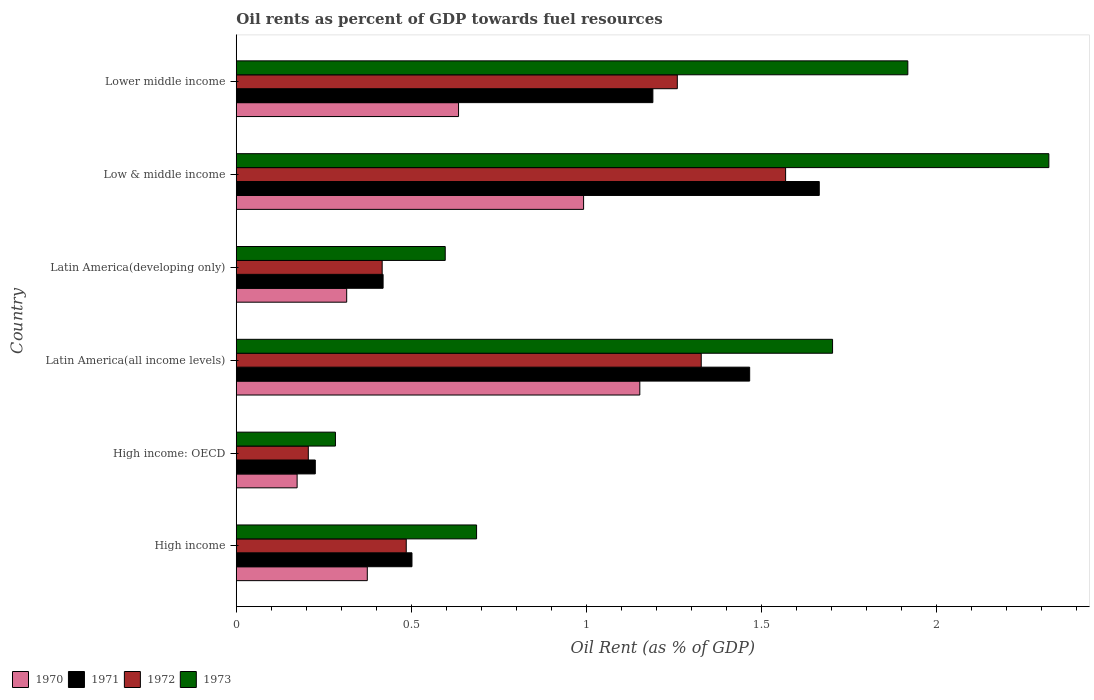How many groups of bars are there?
Offer a terse response. 6. Are the number of bars on each tick of the Y-axis equal?
Give a very brief answer. Yes. How many bars are there on the 6th tick from the top?
Your answer should be compact. 4. How many bars are there on the 2nd tick from the bottom?
Offer a very short reply. 4. What is the oil rent in 1973 in Latin America(developing only)?
Offer a terse response. 0.6. Across all countries, what is the maximum oil rent in 1973?
Keep it short and to the point. 2.32. Across all countries, what is the minimum oil rent in 1971?
Ensure brevity in your answer.  0.23. In which country was the oil rent in 1970 maximum?
Ensure brevity in your answer.  Latin America(all income levels). In which country was the oil rent in 1972 minimum?
Keep it short and to the point. High income: OECD. What is the total oil rent in 1973 in the graph?
Ensure brevity in your answer.  7.51. What is the difference between the oil rent in 1972 in High income and that in High income: OECD?
Offer a very short reply. 0.28. What is the difference between the oil rent in 1972 in Latin America(all income levels) and the oil rent in 1973 in High income: OECD?
Give a very brief answer. 1.04. What is the average oil rent in 1971 per country?
Your response must be concise. 0.91. What is the difference between the oil rent in 1971 and oil rent in 1970 in Latin America(all income levels)?
Your response must be concise. 0.31. In how many countries, is the oil rent in 1973 greater than 1.9 %?
Ensure brevity in your answer.  2. What is the ratio of the oil rent in 1973 in High income to that in High income: OECD?
Your answer should be compact. 2.42. Is the difference between the oil rent in 1971 in High income and Low & middle income greater than the difference between the oil rent in 1970 in High income and Low & middle income?
Ensure brevity in your answer.  No. What is the difference between the highest and the second highest oil rent in 1972?
Your response must be concise. 0.24. What is the difference between the highest and the lowest oil rent in 1971?
Offer a terse response. 1.44. In how many countries, is the oil rent in 1972 greater than the average oil rent in 1972 taken over all countries?
Ensure brevity in your answer.  3. Is the sum of the oil rent in 1971 in High income and Latin America(developing only) greater than the maximum oil rent in 1972 across all countries?
Keep it short and to the point. No. What does the 2nd bar from the top in High income represents?
Keep it short and to the point. 1972. What does the 1st bar from the bottom in Latin America(developing only) represents?
Offer a very short reply. 1970. How many bars are there?
Ensure brevity in your answer.  24. Does the graph contain any zero values?
Give a very brief answer. No. Where does the legend appear in the graph?
Give a very brief answer. Bottom left. How many legend labels are there?
Keep it short and to the point. 4. How are the legend labels stacked?
Make the answer very short. Horizontal. What is the title of the graph?
Provide a succinct answer. Oil rents as percent of GDP towards fuel resources. Does "1995" appear as one of the legend labels in the graph?
Your response must be concise. No. What is the label or title of the X-axis?
Offer a terse response. Oil Rent (as % of GDP). What is the Oil Rent (as % of GDP) of 1970 in High income?
Give a very brief answer. 0.37. What is the Oil Rent (as % of GDP) of 1971 in High income?
Ensure brevity in your answer.  0.5. What is the Oil Rent (as % of GDP) of 1972 in High income?
Keep it short and to the point. 0.49. What is the Oil Rent (as % of GDP) in 1973 in High income?
Provide a short and direct response. 0.69. What is the Oil Rent (as % of GDP) in 1970 in High income: OECD?
Offer a terse response. 0.17. What is the Oil Rent (as % of GDP) of 1971 in High income: OECD?
Offer a very short reply. 0.23. What is the Oil Rent (as % of GDP) of 1972 in High income: OECD?
Provide a short and direct response. 0.21. What is the Oil Rent (as % of GDP) in 1973 in High income: OECD?
Provide a succinct answer. 0.28. What is the Oil Rent (as % of GDP) of 1970 in Latin America(all income levels)?
Ensure brevity in your answer.  1.15. What is the Oil Rent (as % of GDP) in 1971 in Latin America(all income levels)?
Give a very brief answer. 1.47. What is the Oil Rent (as % of GDP) in 1972 in Latin America(all income levels)?
Ensure brevity in your answer.  1.33. What is the Oil Rent (as % of GDP) in 1973 in Latin America(all income levels)?
Offer a very short reply. 1.7. What is the Oil Rent (as % of GDP) in 1970 in Latin America(developing only)?
Your answer should be compact. 0.32. What is the Oil Rent (as % of GDP) in 1971 in Latin America(developing only)?
Keep it short and to the point. 0.42. What is the Oil Rent (as % of GDP) in 1972 in Latin America(developing only)?
Provide a short and direct response. 0.42. What is the Oil Rent (as % of GDP) in 1973 in Latin America(developing only)?
Offer a terse response. 0.6. What is the Oil Rent (as % of GDP) of 1970 in Low & middle income?
Keep it short and to the point. 0.99. What is the Oil Rent (as % of GDP) of 1971 in Low & middle income?
Your answer should be very brief. 1.67. What is the Oil Rent (as % of GDP) of 1972 in Low & middle income?
Offer a terse response. 1.57. What is the Oil Rent (as % of GDP) in 1973 in Low & middle income?
Ensure brevity in your answer.  2.32. What is the Oil Rent (as % of GDP) in 1970 in Lower middle income?
Your answer should be compact. 0.63. What is the Oil Rent (as % of GDP) of 1971 in Lower middle income?
Provide a succinct answer. 1.19. What is the Oil Rent (as % of GDP) in 1972 in Lower middle income?
Offer a terse response. 1.26. What is the Oil Rent (as % of GDP) of 1973 in Lower middle income?
Your answer should be very brief. 1.92. Across all countries, what is the maximum Oil Rent (as % of GDP) of 1970?
Make the answer very short. 1.15. Across all countries, what is the maximum Oil Rent (as % of GDP) of 1971?
Make the answer very short. 1.67. Across all countries, what is the maximum Oil Rent (as % of GDP) of 1972?
Offer a very short reply. 1.57. Across all countries, what is the maximum Oil Rent (as % of GDP) of 1973?
Provide a short and direct response. 2.32. Across all countries, what is the minimum Oil Rent (as % of GDP) of 1970?
Give a very brief answer. 0.17. Across all countries, what is the minimum Oil Rent (as % of GDP) of 1971?
Give a very brief answer. 0.23. Across all countries, what is the minimum Oil Rent (as % of GDP) of 1972?
Offer a very short reply. 0.21. Across all countries, what is the minimum Oil Rent (as % of GDP) of 1973?
Offer a very short reply. 0.28. What is the total Oil Rent (as % of GDP) of 1970 in the graph?
Keep it short and to the point. 3.64. What is the total Oil Rent (as % of GDP) in 1971 in the graph?
Keep it short and to the point. 5.47. What is the total Oil Rent (as % of GDP) of 1972 in the graph?
Provide a succinct answer. 5.27. What is the total Oil Rent (as % of GDP) in 1973 in the graph?
Your answer should be very brief. 7.51. What is the difference between the Oil Rent (as % of GDP) in 1970 in High income and that in High income: OECD?
Make the answer very short. 0.2. What is the difference between the Oil Rent (as % of GDP) of 1971 in High income and that in High income: OECD?
Provide a succinct answer. 0.28. What is the difference between the Oil Rent (as % of GDP) in 1972 in High income and that in High income: OECD?
Make the answer very short. 0.28. What is the difference between the Oil Rent (as % of GDP) in 1973 in High income and that in High income: OECD?
Your answer should be compact. 0.4. What is the difference between the Oil Rent (as % of GDP) in 1970 in High income and that in Latin America(all income levels)?
Your answer should be very brief. -0.78. What is the difference between the Oil Rent (as % of GDP) of 1971 in High income and that in Latin America(all income levels)?
Ensure brevity in your answer.  -0.96. What is the difference between the Oil Rent (as % of GDP) in 1972 in High income and that in Latin America(all income levels)?
Give a very brief answer. -0.84. What is the difference between the Oil Rent (as % of GDP) of 1973 in High income and that in Latin America(all income levels)?
Offer a terse response. -1.02. What is the difference between the Oil Rent (as % of GDP) in 1970 in High income and that in Latin America(developing only)?
Offer a very short reply. 0.06. What is the difference between the Oil Rent (as % of GDP) of 1971 in High income and that in Latin America(developing only)?
Your answer should be very brief. 0.08. What is the difference between the Oil Rent (as % of GDP) in 1972 in High income and that in Latin America(developing only)?
Make the answer very short. 0.07. What is the difference between the Oil Rent (as % of GDP) in 1973 in High income and that in Latin America(developing only)?
Make the answer very short. 0.09. What is the difference between the Oil Rent (as % of GDP) in 1970 in High income and that in Low & middle income?
Provide a succinct answer. -0.62. What is the difference between the Oil Rent (as % of GDP) of 1971 in High income and that in Low & middle income?
Offer a terse response. -1.16. What is the difference between the Oil Rent (as % of GDP) of 1972 in High income and that in Low & middle income?
Provide a succinct answer. -1.08. What is the difference between the Oil Rent (as % of GDP) in 1973 in High income and that in Low & middle income?
Ensure brevity in your answer.  -1.63. What is the difference between the Oil Rent (as % of GDP) in 1970 in High income and that in Lower middle income?
Offer a terse response. -0.26. What is the difference between the Oil Rent (as % of GDP) of 1971 in High income and that in Lower middle income?
Offer a very short reply. -0.69. What is the difference between the Oil Rent (as % of GDP) in 1972 in High income and that in Lower middle income?
Your answer should be very brief. -0.77. What is the difference between the Oil Rent (as % of GDP) of 1973 in High income and that in Lower middle income?
Your answer should be very brief. -1.23. What is the difference between the Oil Rent (as % of GDP) in 1970 in High income: OECD and that in Latin America(all income levels)?
Provide a succinct answer. -0.98. What is the difference between the Oil Rent (as % of GDP) in 1971 in High income: OECD and that in Latin America(all income levels)?
Your answer should be compact. -1.24. What is the difference between the Oil Rent (as % of GDP) in 1972 in High income: OECD and that in Latin America(all income levels)?
Offer a very short reply. -1.12. What is the difference between the Oil Rent (as % of GDP) in 1973 in High income: OECD and that in Latin America(all income levels)?
Your answer should be very brief. -1.42. What is the difference between the Oil Rent (as % of GDP) of 1970 in High income: OECD and that in Latin America(developing only)?
Your answer should be very brief. -0.14. What is the difference between the Oil Rent (as % of GDP) of 1971 in High income: OECD and that in Latin America(developing only)?
Keep it short and to the point. -0.19. What is the difference between the Oil Rent (as % of GDP) of 1972 in High income: OECD and that in Latin America(developing only)?
Give a very brief answer. -0.21. What is the difference between the Oil Rent (as % of GDP) in 1973 in High income: OECD and that in Latin America(developing only)?
Offer a very short reply. -0.31. What is the difference between the Oil Rent (as % of GDP) in 1970 in High income: OECD and that in Low & middle income?
Provide a succinct answer. -0.82. What is the difference between the Oil Rent (as % of GDP) in 1971 in High income: OECD and that in Low & middle income?
Your response must be concise. -1.44. What is the difference between the Oil Rent (as % of GDP) in 1972 in High income: OECD and that in Low & middle income?
Your answer should be compact. -1.36. What is the difference between the Oil Rent (as % of GDP) of 1973 in High income: OECD and that in Low & middle income?
Ensure brevity in your answer.  -2.04. What is the difference between the Oil Rent (as % of GDP) of 1970 in High income: OECD and that in Lower middle income?
Provide a succinct answer. -0.46. What is the difference between the Oil Rent (as % of GDP) in 1971 in High income: OECD and that in Lower middle income?
Make the answer very short. -0.96. What is the difference between the Oil Rent (as % of GDP) of 1972 in High income: OECD and that in Lower middle income?
Offer a very short reply. -1.05. What is the difference between the Oil Rent (as % of GDP) of 1973 in High income: OECD and that in Lower middle income?
Ensure brevity in your answer.  -1.64. What is the difference between the Oil Rent (as % of GDP) of 1970 in Latin America(all income levels) and that in Latin America(developing only)?
Make the answer very short. 0.84. What is the difference between the Oil Rent (as % of GDP) of 1971 in Latin America(all income levels) and that in Latin America(developing only)?
Give a very brief answer. 1.05. What is the difference between the Oil Rent (as % of GDP) in 1972 in Latin America(all income levels) and that in Latin America(developing only)?
Your answer should be compact. 0.91. What is the difference between the Oil Rent (as % of GDP) of 1973 in Latin America(all income levels) and that in Latin America(developing only)?
Provide a short and direct response. 1.11. What is the difference between the Oil Rent (as % of GDP) of 1970 in Latin America(all income levels) and that in Low & middle income?
Provide a short and direct response. 0.16. What is the difference between the Oil Rent (as % of GDP) in 1971 in Latin America(all income levels) and that in Low & middle income?
Offer a very short reply. -0.2. What is the difference between the Oil Rent (as % of GDP) of 1972 in Latin America(all income levels) and that in Low & middle income?
Ensure brevity in your answer.  -0.24. What is the difference between the Oil Rent (as % of GDP) of 1973 in Latin America(all income levels) and that in Low & middle income?
Your answer should be very brief. -0.62. What is the difference between the Oil Rent (as % of GDP) in 1970 in Latin America(all income levels) and that in Lower middle income?
Your response must be concise. 0.52. What is the difference between the Oil Rent (as % of GDP) in 1971 in Latin America(all income levels) and that in Lower middle income?
Offer a terse response. 0.28. What is the difference between the Oil Rent (as % of GDP) of 1972 in Latin America(all income levels) and that in Lower middle income?
Offer a terse response. 0.07. What is the difference between the Oil Rent (as % of GDP) of 1973 in Latin America(all income levels) and that in Lower middle income?
Give a very brief answer. -0.21. What is the difference between the Oil Rent (as % of GDP) in 1970 in Latin America(developing only) and that in Low & middle income?
Your answer should be very brief. -0.68. What is the difference between the Oil Rent (as % of GDP) in 1971 in Latin America(developing only) and that in Low & middle income?
Offer a very short reply. -1.25. What is the difference between the Oil Rent (as % of GDP) in 1972 in Latin America(developing only) and that in Low & middle income?
Your answer should be very brief. -1.15. What is the difference between the Oil Rent (as % of GDP) in 1973 in Latin America(developing only) and that in Low & middle income?
Your response must be concise. -1.72. What is the difference between the Oil Rent (as % of GDP) of 1970 in Latin America(developing only) and that in Lower middle income?
Offer a terse response. -0.32. What is the difference between the Oil Rent (as % of GDP) of 1971 in Latin America(developing only) and that in Lower middle income?
Offer a terse response. -0.77. What is the difference between the Oil Rent (as % of GDP) of 1972 in Latin America(developing only) and that in Lower middle income?
Your response must be concise. -0.84. What is the difference between the Oil Rent (as % of GDP) of 1973 in Latin America(developing only) and that in Lower middle income?
Offer a terse response. -1.32. What is the difference between the Oil Rent (as % of GDP) of 1970 in Low & middle income and that in Lower middle income?
Ensure brevity in your answer.  0.36. What is the difference between the Oil Rent (as % of GDP) of 1971 in Low & middle income and that in Lower middle income?
Ensure brevity in your answer.  0.48. What is the difference between the Oil Rent (as % of GDP) in 1972 in Low & middle income and that in Lower middle income?
Keep it short and to the point. 0.31. What is the difference between the Oil Rent (as % of GDP) of 1973 in Low & middle income and that in Lower middle income?
Ensure brevity in your answer.  0.4. What is the difference between the Oil Rent (as % of GDP) of 1970 in High income and the Oil Rent (as % of GDP) of 1971 in High income: OECD?
Keep it short and to the point. 0.15. What is the difference between the Oil Rent (as % of GDP) in 1970 in High income and the Oil Rent (as % of GDP) in 1972 in High income: OECD?
Offer a terse response. 0.17. What is the difference between the Oil Rent (as % of GDP) of 1970 in High income and the Oil Rent (as % of GDP) of 1973 in High income: OECD?
Provide a succinct answer. 0.09. What is the difference between the Oil Rent (as % of GDP) of 1971 in High income and the Oil Rent (as % of GDP) of 1972 in High income: OECD?
Provide a short and direct response. 0.3. What is the difference between the Oil Rent (as % of GDP) of 1971 in High income and the Oil Rent (as % of GDP) of 1973 in High income: OECD?
Make the answer very short. 0.22. What is the difference between the Oil Rent (as % of GDP) in 1972 in High income and the Oil Rent (as % of GDP) in 1973 in High income: OECD?
Your answer should be compact. 0.2. What is the difference between the Oil Rent (as % of GDP) in 1970 in High income and the Oil Rent (as % of GDP) in 1971 in Latin America(all income levels)?
Ensure brevity in your answer.  -1.09. What is the difference between the Oil Rent (as % of GDP) in 1970 in High income and the Oil Rent (as % of GDP) in 1972 in Latin America(all income levels)?
Your response must be concise. -0.95. What is the difference between the Oil Rent (as % of GDP) of 1970 in High income and the Oil Rent (as % of GDP) of 1973 in Latin America(all income levels)?
Keep it short and to the point. -1.33. What is the difference between the Oil Rent (as % of GDP) of 1971 in High income and the Oil Rent (as % of GDP) of 1972 in Latin America(all income levels)?
Your answer should be compact. -0.83. What is the difference between the Oil Rent (as % of GDP) of 1971 in High income and the Oil Rent (as % of GDP) of 1973 in Latin America(all income levels)?
Provide a succinct answer. -1.2. What is the difference between the Oil Rent (as % of GDP) of 1972 in High income and the Oil Rent (as % of GDP) of 1973 in Latin America(all income levels)?
Ensure brevity in your answer.  -1.22. What is the difference between the Oil Rent (as % of GDP) in 1970 in High income and the Oil Rent (as % of GDP) in 1971 in Latin America(developing only)?
Your answer should be very brief. -0.05. What is the difference between the Oil Rent (as % of GDP) in 1970 in High income and the Oil Rent (as % of GDP) in 1972 in Latin America(developing only)?
Give a very brief answer. -0.04. What is the difference between the Oil Rent (as % of GDP) of 1970 in High income and the Oil Rent (as % of GDP) of 1973 in Latin America(developing only)?
Your answer should be compact. -0.22. What is the difference between the Oil Rent (as % of GDP) in 1971 in High income and the Oil Rent (as % of GDP) in 1972 in Latin America(developing only)?
Ensure brevity in your answer.  0.09. What is the difference between the Oil Rent (as % of GDP) in 1971 in High income and the Oil Rent (as % of GDP) in 1973 in Latin America(developing only)?
Provide a short and direct response. -0.1. What is the difference between the Oil Rent (as % of GDP) in 1972 in High income and the Oil Rent (as % of GDP) in 1973 in Latin America(developing only)?
Ensure brevity in your answer.  -0.11. What is the difference between the Oil Rent (as % of GDP) in 1970 in High income and the Oil Rent (as % of GDP) in 1971 in Low & middle income?
Offer a terse response. -1.29. What is the difference between the Oil Rent (as % of GDP) in 1970 in High income and the Oil Rent (as % of GDP) in 1972 in Low & middle income?
Offer a terse response. -1.19. What is the difference between the Oil Rent (as % of GDP) in 1970 in High income and the Oil Rent (as % of GDP) in 1973 in Low & middle income?
Your answer should be very brief. -1.95. What is the difference between the Oil Rent (as % of GDP) of 1971 in High income and the Oil Rent (as % of GDP) of 1972 in Low & middle income?
Make the answer very short. -1.07. What is the difference between the Oil Rent (as % of GDP) of 1971 in High income and the Oil Rent (as % of GDP) of 1973 in Low & middle income?
Your response must be concise. -1.82. What is the difference between the Oil Rent (as % of GDP) of 1972 in High income and the Oil Rent (as % of GDP) of 1973 in Low & middle income?
Give a very brief answer. -1.84. What is the difference between the Oil Rent (as % of GDP) in 1970 in High income and the Oil Rent (as % of GDP) in 1971 in Lower middle income?
Provide a short and direct response. -0.82. What is the difference between the Oil Rent (as % of GDP) in 1970 in High income and the Oil Rent (as % of GDP) in 1972 in Lower middle income?
Keep it short and to the point. -0.89. What is the difference between the Oil Rent (as % of GDP) of 1970 in High income and the Oil Rent (as % of GDP) of 1973 in Lower middle income?
Offer a very short reply. -1.54. What is the difference between the Oil Rent (as % of GDP) of 1971 in High income and the Oil Rent (as % of GDP) of 1972 in Lower middle income?
Your answer should be compact. -0.76. What is the difference between the Oil Rent (as % of GDP) of 1971 in High income and the Oil Rent (as % of GDP) of 1973 in Lower middle income?
Make the answer very short. -1.42. What is the difference between the Oil Rent (as % of GDP) of 1972 in High income and the Oil Rent (as % of GDP) of 1973 in Lower middle income?
Give a very brief answer. -1.43. What is the difference between the Oil Rent (as % of GDP) in 1970 in High income: OECD and the Oil Rent (as % of GDP) in 1971 in Latin America(all income levels)?
Provide a short and direct response. -1.29. What is the difference between the Oil Rent (as % of GDP) in 1970 in High income: OECD and the Oil Rent (as % of GDP) in 1972 in Latin America(all income levels)?
Make the answer very short. -1.15. What is the difference between the Oil Rent (as % of GDP) of 1970 in High income: OECD and the Oil Rent (as % of GDP) of 1973 in Latin America(all income levels)?
Provide a short and direct response. -1.53. What is the difference between the Oil Rent (as % of GDP) of 1971 in High income: OECD and the Oil Rent (as % of GDP) of 1972 in Latin America(all income levels)?
Your answer should be compact. -1.1. What is the difference between the Oil Rent (as % of GDP) of 1971 in High income: OECD and the Oil Rent (as % of GDP) of 1973 in Latin America(all income levels)?
Your answer should be very brief. -1.48. What is the difference between the Oil Rent (as % of GDP) in 1972 in High income: OECD and the Oil Rent (as % of GDP) in 1973 in Latin America(all income levels)?
Provide a short and direct response. -1.5. What is the difference between the Oil Rent (as % of GDP) of 1970 in High income: OECD and the Oil Rent (as % of GDP) of 1971 in Latin America(developing only)?
Provide a short and direct response. -0.25. What is the difference between the Oil Rent (as % of GDP) of 1970 in High income: OECD and the Oil Rent (as % of GDP) of 1972 in Latin America(developing only)?
Your answer should be compact. -0.24. What is the difference between the Oil Rent (as % of GDP) of 1970 in High income: OECD and the Oil Rent (as % of GDP) of 1973 in Latin America(developing only)?
Ensure brevity in your answer.  -0.42. What is the difference between the Oil Rent (as % of GDP) in 1971 in High income: OECD and the Oil Rent (as % of GDP) in 1972 in Latin America(developing only)?
Provide a succinct answer. -0.19. What is the difference between the Oil Rent (as % of GDP) in 1971 in High income: OECD and the Oil Rent (as % of GDP) in 1973 in Latin America(developing only)?
Provide a short and direct response. -0.37. What is the difference between the Oil Rent (as % of GDP) in 1972 in High income: OECD and the Oil Rent (as % of GDP) in 1973 in Latin America(developing only)?
Ensure brevity in your answer.  -0.39. What is the difference between the Oil Rent (as % of GDP) of 1970 in High income: OECD and the Oil Rent (as % of GDP) of 1971 in Low & middle income?
Provide a succinct answer. -1.49. What is the difference between the Oil Rent (as % of GDP) in 1970 in High income: OECD and the Oil Rent (as % of GDP) in 1972 in Low & middle income?
Keep it short and to the point. -1.4. What is the difference between the Oil Rent (as % of GDP) in 1970 in High income: OECD and the Oil Rent (as % of GDP) in 1973 in Low & middle income?
Ensure brevity in your answer.  -2.15. What is the difference between the Oil Rent (as % of GDP) in 1971 in High income: OECD and the Oil Rent (as % of GDP) in 1972 in Low & middle income?
Make the answer very short. -1.34. What is the difference between the Oil Rent (as % of GDP) in 1971 in High income: OECD and the Oil Rent (as % of GDP) in 1973 in Low & middle income?
Your response must be concise. -2.1. What is the difference between the Oil Rent (as % of GDP) of 1972 in High income: OECD and the Oil Rent (as % of GDP) of 1973 in Low & middle income?
Provide a succinct answer. -2.12. What is the difference between the Oil Rent (as % of GDP) in 1970 in High income: OECD and the Oil Rent (as % of GDP) in 1971 in Lower middle income?
Your response must be concise. -1.02. What is the difference between the Oil Rent (as % of GDP) in 1970 in High income: OECD and the Oil Rent (as % of GDP) in 1972 in Lower middle income?
Ensure brevity in your answer.  -1.09. What is the difference between the Oil Rent (as % of GDP) of 1970 in High income: OECD and the Oil Rent (as % of GDP) of 1973 in Lower middle income?
Make the answer very short. -1.74. What is the difference between the Oil Rent (as % of GDP) in 1971 in High income: OECD and the Oil Rent (as % of GDP) in 1972 in Lower middle income?
Provide a succinct answer. -1.03. What is the difference between the Oil Rent (as % of GDP) of 1971 in High income: OECD and the Oil Rent (as % of GDP) of 1973 in Lower middle income?
Make the answer very short. -1.69. What is the difference between the Oil Rent (as % of GDP) of 1972 in High income: OECD and the Oil Rent (as % of GDP) of 1973 in Lower middle income?
Offer a terse response. -1.71. What is the difference between the Oil Rent (as % of GDP) of 1970 in Latin America(all income levels) and the Oil Rent (as % of GDP) of 1971 in Latin America(developing only)?
Give a very brief answer. 0.73. What is the difference between the Oil Rent (as % of GDP) of 1970 in Latin America(all income levels) and the Oil Rent (as % of GDP) of 1972 in Latin America(developing only)?
Give a very brief answer. 0.74. What is the difference between the Oil Rent (as % of GDP) in 1970 in Latin America(all income levels) and the Oil Rent (as % of GDP) in 1973 in Latin America(developing only)?
Make the answer very short. 0.56. What is the difference between the Oil Rent (as % of GDP) of 1971 in Latin America(all income levels) and the Oil Rent (as % of GDP) of 1972 in Latin America(developing only)?
Make the answer very short. 1.05. What is the difference between the Oil Rent (as % of GDP) in 1971 in Latin America(all income levels) and the Oil Rent (as % of GDP) in 1973 in Latin America(developing only)?
Provide a short and direct response. 0.87. What is the difference between the Oil Rent (as % of GDP) of 1972 in Latin America(all income levels) and the Oil Rent (as % of GDP) of 1973 in Latin America(developing only)?
Offer a very short reply. 0.73. What is the difference between the Oil Rent (as % of GDP) in 1970 in Latin America(all income levels) and the Oil Rent (as % of GDP) in 1971 in Low & middle income?
Ensure brevity in your answer.  -0.51. What is the difference between the Oil Rent (as % of GDP) in 1970 in Latin America(all income levels) and the Oil Rent (as % of GDP) in 1972 in Low & middle income?
Give a very brief answer. -0.42. What is the difference between the Oil Rent (as % of GDP) in 1970 in Latin America(all income levels) and the Oil Rent (as % of GDP) in 1973 in Low & middle income?
Make the answer very short. -1.17. What is the difference between the Oil Rent (as % of GDP) in 1971 in Latin America(all income levels) and the Oil Rent (as % of GDP) in 1972 in Low & middle income?
Your response must be concise. -0.1. What is the difference between the Oil Rent (as % of GDP) in 1971 in Latin America(all income levels) and the Oil Rent (as % of GDP) in 1973 in Low & middle income?
Give a very brief answer. -0.85. What is the difference between the Oil Rent (as % of GDP) in 1972 in Latin America(all income levels) and the Oil Rent (as % of GDP) in 1973 in Low & middle income?
Provide a succinct answer. -0.99. What is the difference between the Oil Rent (as % of GDP) in 1970 in Latin America(all income levels) and the Oil Rent (as % of GDP) in 1971 in Lower middle income?
Your answer should be compact. -0.04. What is the difference between the Oil Rent (as % of GDP) in 1970 in Latin America(all income levels) and the Oil Rent (as % of GDP) in 1972 in Lower middle income?
Your answer should be very brief. -0.11. What is the difference between the Oil Rent (as % of GDP) of 1970 in Latin America(all income levels) and the Oil Rent (as % of GDP) of 1973 in Lower middle income?
Offer a terse response. -0.77. What is the difference between the Oil Rent (as % of GDP) of 1971 in Latin America(all income levels) and the Oil Rent (as % of GDP) of 1972 in Lower middle income?
Ensure brevity in your answer.  0.21. What is the difference between the Oil Rent (as % of GDP) in 1971 in Latin America(all income levels) and the Oil Rent (as % of GDP) in 1973 in Lower middle income?
Offer a very short reply. -0.45. What is the difference between the Oil Rent (as % of GDP) in 1972 in Latin America(all income levels) and the Oil Rent (as % of GDP) in 1973 in Lower middle income?
Your answer should be compact. -0.59. What is the difference between the Oil Rent (as % of GDP) in 1970 in Latin America(developing only) and the Oil Rent (as % of GDP) in 1971 in Low & middle income?
Give a very brief answer. -1.35. What is the difference between the Oil Rent (as % of GDP) in 1970 in Latin America(developing only) and the Oil Rent (as % of GDP) in 1972 in Low & middle income?
Provide a succinct answer. -1.25. What is the difference between the Oil Rent (as % of GDP) in 1970 in Latin America(developing only) and the Oil Rent (as % of GDP) in 1973 in Low & middle income?
Provide a succinct answer. -2.01. What is the difference between the Oil Rent (as % of GDP) of 1971 in Latin America(developing only) and the Oil Rent (as % of GDP) of 1972 in Low & middle income?
Make the answer very short. -1.15. What is the difference between the Oil Rent (as % of GDP) of 1971 in Latin America(developing only) and the Oil Rent (as % of GDP) of 1973 in Low & middle income?
Your answer should be compact. -1.9. What is the difference between the Oil Rent (as % of GDP) of 1972 in Latin America(developing only) and the Oil Rent (as % of GDP) of 1973 in Low & middle income?
Give a very brief answer. -1.9. What is the difference between the Oil Rent (as % of GDP) of 1970 in Latin America(developing only) and the Oil Rent (as % of GDP) of 1971 in Lower middle income?
Ensure brevity in your answer.  -0.87. What is the difference between the Oil Rent (as % of GDP) in 1970 in Latin America(developing only) and the Oil Rent (as % of GDP) in 1972 in Lower middle income?
Offer a very short reply. -0.94. What is the difference between the Oil Rent (as % of GDP) in 1970 in Latin America(developing only) and the Oil Rent (as % of GDP) in 1973 in Lower middle income?
Your answer should be very brief. -1.6. What is the difference between the Oil Rent (as % of GDP) of 1971 in Latin America(developing only) and the Oil Rent (as % of GDP) of 1972 in Lower middle income?
Offer a terse response. -0.84. What is the difference between the Oil Rent (as % of GDP) of 1971 in Latin America(developing only) and the Oil Rent (as % of GDP) of 1973 in Lower middle income?
Your answer should be very brief. -1.5. What is the difference between the Oil Rent (as % of GDP) in 1972 in Latin America(developing only) and the Oil Rent (as % of GDP) in 1973 in Lower middle income?
Offer a very short reply. -1.5. What is the difference between the Oil Rent (as % of GDP) of 1970 in Low & middle income and the Oil Rent (as % of GDP) of 1971 in Lower middle income?
Keep it short and to the point. -0.2. What is the difference between the Oil Rent (as % of GDP) of 1970 in Low & middle income and the Oil Rent (as % of GDP) of 1972 in Lower middle income?
Your response must be concise. -0.27. What is the difference between the Oil Rent (as % of GDP) in 1970 in Low & middle income and the Oil Rent (as % of GDP) in 1973 in Lower middle income?
Make the answer very short. -0.93. What is the difference between the Oil Rent (as % of GDP) in 1971 in Low & middle income and the Oil Rent (as % of GDP) in 1972 in Lower middle income?
Your answer should be very brief. 0.41. What is the difference between the Oil Rent (as % of GDP) in 1971 in Low & middle income and the Oil Rent (as % of GDP) in 1973 in Lower middle income?
Offer a terse response. -0.25. What is the difference between the Oil Rent (as % of GDP) of 1972 in Low & middle income and the Oil Rent (as % of GDP) of 1973 in Lower middle income?
Ensure brevity in your answer.  -0.35. What is the average Oil Rent (as % of GDP) of 1970 per country?
Offer a very short reply. 0.61. What is the average Oil Rent (as % of GDP) of 1971 per country?
Give a very brief answer. 0.91. What is the average Oil Rent (as % of GDP) in 1972 per country?
Offer a very short reply. 0.88. What is the average Oil Rent (as % of GDP) in 1973 per country?
Make the answer very short. 1.25. What is the difference between the Oil Rent (as % of GDP) of 1970 and Oil Rent (as % of GDP) of 1971 in High income?
Your response must be concise. -0.13. What is the difference between the Oil Rent (as % of GDP) of 1970 and Oil Rent (as % of GDP) of 1972 in High income?
Ensure brevity in your answer.  -0.11. What is the difference between the Oil Rent (as % of GDP) of 1970 and Oil Rent (as % of GDP) of 1973 in High income?
Your answer should be very brief. -0.31. What is the difference between the Oil Rent (as % of GDP) in 1971 and Oil Rent (as % of GDP) in 1972 in High income?
Provide a succinct answer. 0.02. What is the difference between the Oil Rent (as % of GDP) in 1971 and Oil Rent (as % of GDP) in 1973 in High income?
Your response must be concise. -0.18. What is the difference between the Oil Rent (as % of GDP) of 1972 and Oil Rent (as % of GDP) of 1973 in High income?
Provide a succinct answer. -0.2. What is the difference between the Oil Rent (as % of GDP) of 1970 and Oil Rent (as % of GDP) of 1971 in High income: OECD?
Ensure brevity in your answer.  -0.05. What is the difference between the Oil Rent (as % of GDP) in 1970 and Oil Rent (as % of GDP) in 1972 in High income: OECD?
Ensure brevity in your answer.  -0.03. What is the difference between the Oil Rent (as % of GDP) of 1970 and Oil Rent (as % of GDP) of 1973 in High income: OECD?
Offer a very short reply. -0.11. What is the difference between the Oil Rent (as % of GDP) of 1971 and Oil Rent (as % of GDP) of 1973 in High income: OECD?
Give a very brief answer. -0.06. What is the difference between the Oil Rent (as % of GDP) of 1972 and Oil Rent (as % of GDP) of 1973 in High income: OECD?
Ensure brevity in your answer.  -0.08. What is the difference between the Oil Rent (as % of GDP) in 1970 and Oil Rent (as % of GDP) in 1971 in Latin America(all income levels)?
Your answer should be compact. -0.31. What is the difference between the Oil Rent (as % of GDP) of 1970 and Oil Rent (as % of GDP) of 1972 in Latin America(all income levels)?
Provide a succinct answer. -0.18. What is the difference between the Oil Rent (as % of GDP) of 1970 and Oil Rent (as % of GDP) of 1973 in Latin America(all income levels)?
Offer a very short reply. -0.55. What is the difference between the Oil Rent (as % of GDP) in 1971 and Oil Rent (as % of GDP) in 1972 in Latin America(all income levels)?
Provide a succinct answer. 0.14. What is the difference between the Oil Rent (as % of GDP) of 1971 and Oil Rent (as % of GDP) of 1973 in Latin America(all income levels)?
Offer a very short reply. -0.24. What is the difference between the Oil Rent (as % of GDP) in 1972 and Oil Rent (as % of GDP) in 1973 in Latin America(all income levels)?
Make the answer very short. -0.38. What is the difference between the Oil Rent (as % of GDP) in 1970 and Oil Rent (as % of GDP) in 1971 in Latin America(developing only)?
Give a very brief answer. -0.1. What is the difference between the Oil Rent (as % of GDP) of 1970 and Oil Rent (as % of GDP) of 1972 in Latin America(developing only)?
Provide a succinct answer. -0.1. What is the difference between the Oil Rent (as % of GDP) in 1970 and Oil Rent (as % of GDP) in 1973 in Latin America(developing only)?
Your answer should be compact. -0.28. What is the difference between the Oil Rent (as % of GDP) in 1971 and Oil Rent (as % of GDP) in 1972 in Latin America(developing only)?
Provide a succinct answer. 0. What is the difference between the Oil Rent (as % of GDP) of 1971 and Oil Rent (as % of GDP) of 1973 in Latin America(developing only)?
Offer a terse response. -0.18. What is the difference between the Oil Rent (as % of GDP) in 1972 and Oil Rent (as % of GDP) in 1973 in Latin America(developing only)?
Provide a short and direct response. -0.18. What is the difference between the Oil Rent (as % of GDP) of 1970 and Oil Rent (as % of GDP) of 1971 in Low & middle income?
Offer a terse response. -0.67. What is the difference between the Oil Rent (as % of GDP) of 1970 and Oil Rent (as % of GDP) of 1972 in Low & middle income?
Ensure brevity in your answer.  -0.58. What is the difference between the Oil Rent (as % of GDP) of 1970 and Oil Rent (as % of GDP) of 1973 in Low & middle income?
Make the answer very short. -1.33. What is the difference between the Oil Rent (as % of GDP) in 1971 and Oil Rent (as % of GDP) in 1972 in Low & middle income?
Keep it short and to the point. 0.1. What is the difference between the Oil Rent (as % of GDP) of 1971 and Oil Rent (as % of GDP) of 1973 in Low & middle income?
Give a very brief answer. -0.66. What is the difference between the Oil Rent (as % of GDP) in 1972 and Oil Rent (as % of GDP) in 1973 in Low & middle income?
Make the answer very short. -0.75. What is the difference between the Oil Rent (as % of GDP) in 1970 and Oil Rent (as % of GDP) in 1971 in Lower middle income?
Provide a short and direct response. -0.56. What is the difference between the Oil Rent (as % of GDP) of 1970 and Oil Rent (as % of GDP) of 1972 in Lower middle income?
Keep it short and to the point. -0.62. What is the difference between the Oil Rent (as % of GDP) of 1970 and Oil Rent (as % of GDP) of 1973 in Lower middle income?
Your response must be concise. -1.28. What is the difference between the Oil Rent (as % of GDP) in 1971 and Oil Rent (as % of GDP) in 1972 in Lower middle income?
Give a very brief answer. -0.07. What is the difference between the Oil Rent (as % of GDP) of 1971 and Oil Rent (as % of GDP) of 1973 in Lower middle income?
Make the answer very short. -0.73. What is the difference between the Oil Rent (as % of GDP) of 1972 and Oil Rent (as % of GDP) of 1973 in Lower middle income?
Provide a short and direct response. -0.66. What is the ratio of the Oil Rent (as % of GDP) of 1970 in High income to that in High income: OECD?
Your answer should be compact. 2.15. What is the ratio of the Oil Rent (as % of GDP) of 1971 in High income to that in High income: OECD?
Keep it short and to the point. 2.22. What is the ratio of the Oil Rent (as % of GDP) of 1972 in High income to that in High income: OECD?
Keep it short and to the point. 2.36. What is the ratio of the Oil Rent (as % of GDP) in 1973 in High income to that in High income: OECD?
Ensure brevity in your answer.  2.42. What is the ratio of the Oil Rent (as % of GDP) in 1970 in High income to that in Latin America(all income levels)?
Ensure brevity in your answer.  0.32. What is the ratio of the Oil Rent (as % of GDP) in 1971 in High income to that in Latin America(all income levels)?
Make the answer very short. 0.34. What is the ratio of the Oil Rent (as % of GDP) of 1972 in High income to that in Latin America(all income levels)?
Ensure brevity in your answer.  0.37. What is the ratio of the Oil Rent (as % of GDP) of 1973 in High income to that in Latin America(all income levels)?
Your answer should be compact. 0.4. What is the ratio of the Oil Rent (as % of GDP) of 1970 in High income to that in Latin America(developing only)?
Keep it short and to the point. 1.19. What is the ratio of the Oil Rent (as % of GDP) of 1971 in High income to that in Latin America(developing only)?
Make the answer very short. 1.2. What is the ratio of the Oil Rent (as % of GDP) in 1972 in High income to that in Latin America(developing only)?
Your answer should be compact. 1.17. What is the ratio of the Oil Rent (as % of GDP) of 1973 in High income to that in Latin America(developing only)?
Provide a succinct answer. 1.15. What is the ratio of the Oil Rent (as % of GDP) of 1970 in High income to that in Low & middle income?
Give a very brief answer. 0.38. What is the ratio of the Oil Rent (as % of GDP) of 1971 in High income to that in Low & middle income?
Your answer should be very brief. 0.3. What is the ratio of the Oil Rent (as % of GDP) in 1972 in High income to that in Low & middle income?
Your response must be concise. 0.31. What is the ratio of the Oil Rent (as % of GDP) in 1973 in High income to that in Low & middle income?
Keep it short and to the point. 0.3. What is the ratio of the Oil Rent (as % of GDP) of 1970 in High income to that in Lower middle income?
Your answer should be compact. 0.59. What is the ratio of the Oil Rent (as % of GDP) of 1971 in High income to that in Lower middle income?
Provide a short and direct response. 0.42. What is the ratio of the Oil Rent (as % of GDP) in 1972 in High income to that in Lower middle income?
Your answer should be very brief. 0.39. What is the ratio of the Oil Rent (as % of GDP) of 1973 in High income to that in Lower middle income?
Provide a succinct answer. 0.36. What is the ratio of the Oil Rent (as % of GDP) of 1970 in High income: OECD to that in Latin America(all income levels)?
Your answer should be very brief. 0.15. What is the ratio of the Oil Rent (as % of GDP) of 1971 in High income: OECD to that in Latin America(all income levels)?
Your answer should be compact. 0.15. What is the ratio of the Oil Rent (as % of GDP) in 1972 in High income: OECD to that in Latin America(all income levels)?
Make the answer very short. 0.15. What is the ratio of the Oil Rent (as % of GDP) of 1973 in High income: OECD to that in Latin America(all income levels)?
Offer a terse response. 0.17. What is the ratio of the Oil Rent (as % of GDP) in 1970 in High income: OECD to that in Latin America(developing only)?
Your response must be concise. 0.55. What is the ratio of the Oil Rent (as % of GDP) of 1971 in High income: OECD to that in Latin America(developing only)?
Offer a terse response. 0.54. What is the ratio of the Oil Rent (as % of GDP) in 1972 in High income: OECD to that in Latin America(developing only)?
Offer a terse response. 0.49. What is the ratio of the Oil Rent (as % of GDP) in 1973 in High income: OECD to that in Latin America(developing only)?
Make the answer very short. 0.47. What is the ratio of the Oil Rent (as % of GDP) in 1970 in High income: OECD to that in Low & middle income?
Keep it short and to the point. 0.18. What is the ratio of the Oil Rent (as % of GDP) in 1971 in High income: OECD to that in Low & middle income?
Your answer should be compact. 0.14. What is the ratio of the Oil Rent (as % of GDP) in 1972 in High income: OECD to that in Low & middle income?
Make the answer very short. 0.13. What is the ratio of the Oil Rent (as % of GDP) in 1973 in High income: OECD to that in Low & middle income?
Provide a succinct answer. 0.12. What is the ratio of the Oil Rent (as % of GDP) in 1970 in High income: OECD to that in Lower middle income?
Provide a succinct answer. 0.27. What is the ratio of the Oil Rent (as % of GDP) of 1971 in High income: OECD to that in Lower middle income?
Offer a very short reply. 0.19. What is the ratio of the Oil Rent (as % of GDP) in 1972 in High income: OECD to that in Lower middle income?
Provide a succinct answer. 0.16. What is the ratio of the Oil Rent (as % of GDP) in 1973 in High income: OECD to that in Lower middle income?
Ensure brevity in your answer.  0.15. What is the ratio of the Oil Rent (as % of GDP) in 1970 in Latin America(all income levels) to that in Latin America(developing only)?
Provide a short and direct response. 3.65. What is the ratio of the Oil Rent (as % of GDP) of 1971 in Latin America(all income levels) to that in Latin America(developing only)?
Your answer should be very brief. 3.5. What is the ratio of the Oil Rent (as % of GDP) in 1972 in Latin America(all income levels) to that in Latin America(developing only)?
Give a very brief answer. 3.19. What is the ratio of the Oil Rent (as % of GDP) of 1973 in Latin America(all income levels) to that in Latin America(developing only)?
Your answer should be very brief. 2.85. What is the ratio of the Oil Rent (as % of GDP) in 1970 in Latin America(all income levels) to that in Low & middle income?
Offer a very short reply. 1.16. What is the ratio of the Oil Rent (as % of GDP) of 1971 in Latin America(all income levels) to that in Low & middle income?
Offer a terse response. 0.88. What is the ratio of the Oil Rent (as % of GDP) of 1972 in Latin America(all income levels) to that in Low & middle income?
Provide a succinct answer. 0.85. What is the ratio of the Oil Rent (as % of GDP) of 1973 in Latin America(all income levels) to that in Low & middle income?
Offer a very short reply. 0.73. What is the ratio of the Oil Rent (as % of GDP) in 1970 in Latin America(all income levels) to that in Lower middle income?
Give a very brief answer. 1.82. What is the ratio of the Oil Rent (as % of GDP) in 1971 in Latin America(all income levels) to that in Lower middle income?
Provide a succinct answer. 1.23. What is the ratio of the Oil Rent (as % of GDP) in 1972 in Latin America(all income levels) to that in Lower middle income?
Provide a short and direct response. 1.05. What is the ratio of the Oil Rent (as % of GDP) in 1973 in Latin America(all income levels) to that in Lower middle income?
Offer a very short reply. 0.89. What is the ratio of the Oil Rent (as % of GDP) in 1970 in Latin America(developing only) to that in Low & middle income?
Your answer should be very brief. 0.32. What is the ratio of the Oil Rent (as % of GDP) of 1971 in Latin America(developing only) to that in Low & middle income?
Your answer should be very brief. 0.25. What is the ratio of the Oil Rent (as % of GDP) of 1972 in Latin America(developing only) to that in Low & middle income?
Your answer should be compact. 0.27. What is the ratio of the Oil Rent (as % of GDP) in 1973 in Latin America(developing only) to that in Low & middle income?
Provide a short and direct response. 0.26. What is the ratio of the Oil Rent (as % of GDP) of 1970 in Latin America(developing only) to that in Lower middle income?
Provide a short and direct response. 0.5. What is the ratio of the Oil Rent (as % of GDP) in 1971 in Latin America(developing only) to that in Lower middle income?
Provide a succinct answer. 0.35. What is the ratio of the Oil Rent (as % of GDP) in 1972 in Latin America(developing only) to that in Lower middle income?
Provide a short and direct response. 0.33. What is the ratio of the Oil Rent (as % of GDP) in 1973 in Latin America(developing only) to that in Lower middle income?
Provide a succinct answer. 0.31. What is the ratio of the Oil Rent (as % of GDP) of 1970 in Low & middle income to that in Lower middle income?
Your answer should be very brief. 1.56. What is the ratio of the Oil Rent (as % of GDP) in 1971 in Low & middle income to that in Lower middle income?
Your answer should be very brief. 1.4. What is the ratio of the Oil Rent (as % of GDP) in 1972 in Low & middle income to that in Lower middle income?
Your answer should be compact. 1.25. What is the ratio of the Oil Rent (as % of GDP) in 1973 in Low & middle income to that in Lower middle income?
Offer a very short reply. 1.21. What is the difference between the highest and the second highest Oil Rent (as % of GDP) in 1970?
Provide a succinct answer. 0.16. What is the difference between the highest and the second highest Oil Rent (as % of GDP) of 1971?
Give a very brief answer. 0.2. What is the difference between the highest and the second highest Oil Rent (as % of GDP) in 1972?
Ensure brevity in your answer.  0.24. What is the difference between the highest and the second highest Oil Rent (as % of GDP) of 1973?
Ensure brevity in your answer.  0.4. What is the difference between the highest and the lowest Oil Rent (as % of GDP) in 1970?
Your response must be concise. 0.98. What is the difference between the highest and the lowest Oil Rent (as % of GDP) in 1971?
Your answer should be compact. 1.44. What is the difference between the highest and the lowest Oil Rent (as % of GDP) of 1972?
Provide a short and direct response. 1.36. What is the difference between the highest and the lowest Oil Rent (as % of GDP) in 1973?
Offer a terse response. 2.04. 